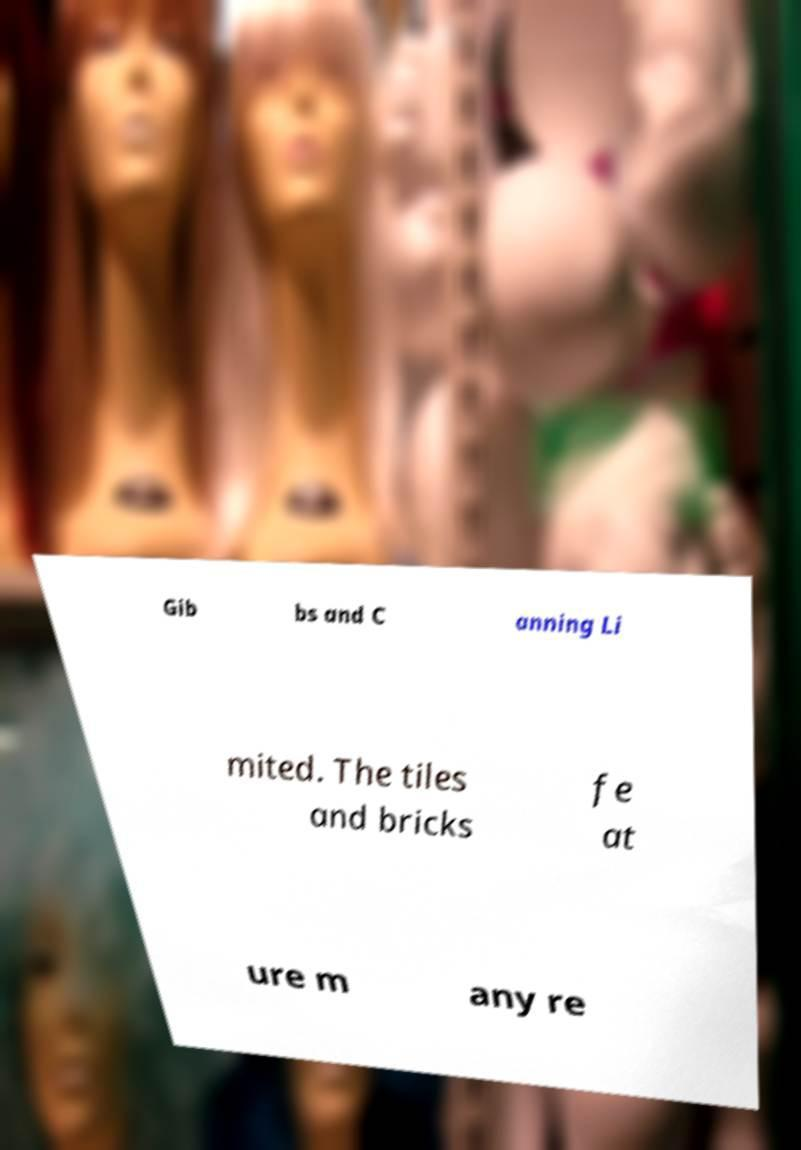Please read and relay the text visible in this image. What does it say? Gib bs and C anning Li mited. The tiles and bricks fe at ure m any re 